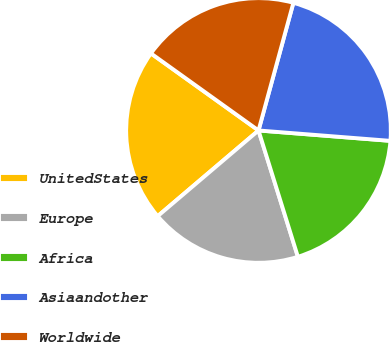Convert chart to OTSL. <chart><loc_0><loc_0><loc_500><loc_500><pie_chart><fcel>UnitedStates<fcel>Europe<fcel>Africa<fcel>Asiaandother<fcel>Worldwide<nl><fcel>21.11%<fcel>18.6%<fcel>18.94%<fcel>22.01%<fcel>19.35%<nl></chart> 